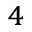<formula> <loc_0><loc_0><loc_500><loc_500>_ { 4 }</formula> 